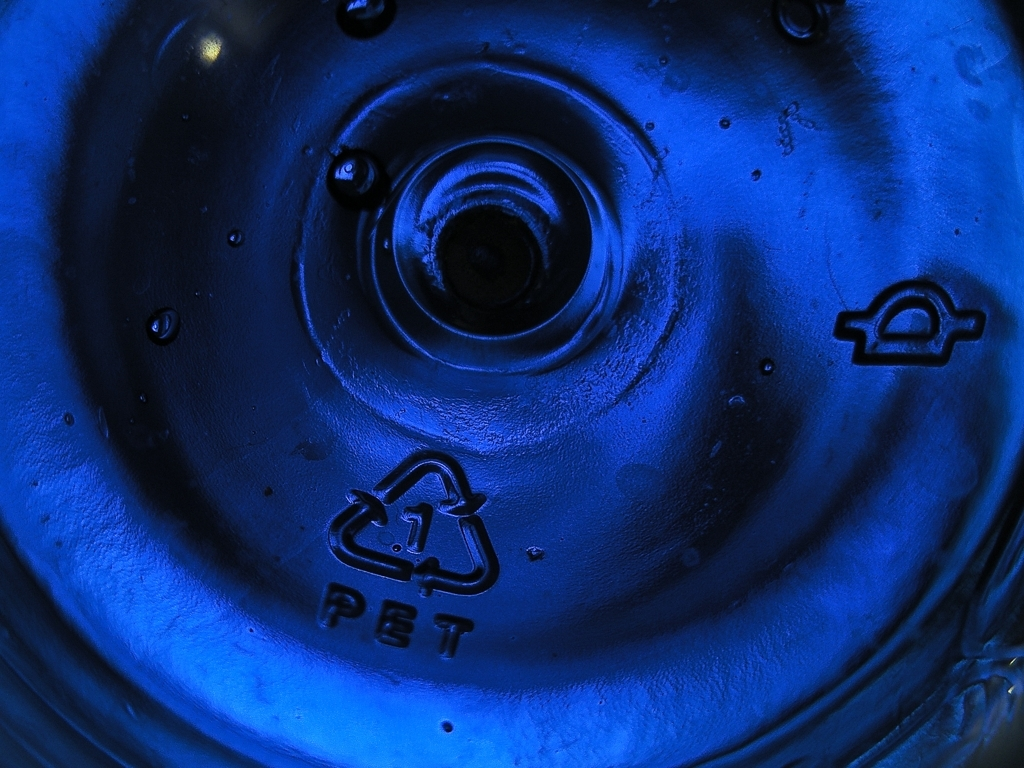What is the primary color theme in this image, and what could it symbolize? The primary color theme in the image is blue, which can be associated with calmness, stability, and perhaps the theme of water, tying back to the object's common use as a beverage container. Blue can also evoke a sense of technology and cleanliness, relevant to the recycling and manufacturing processes of PET materials. 